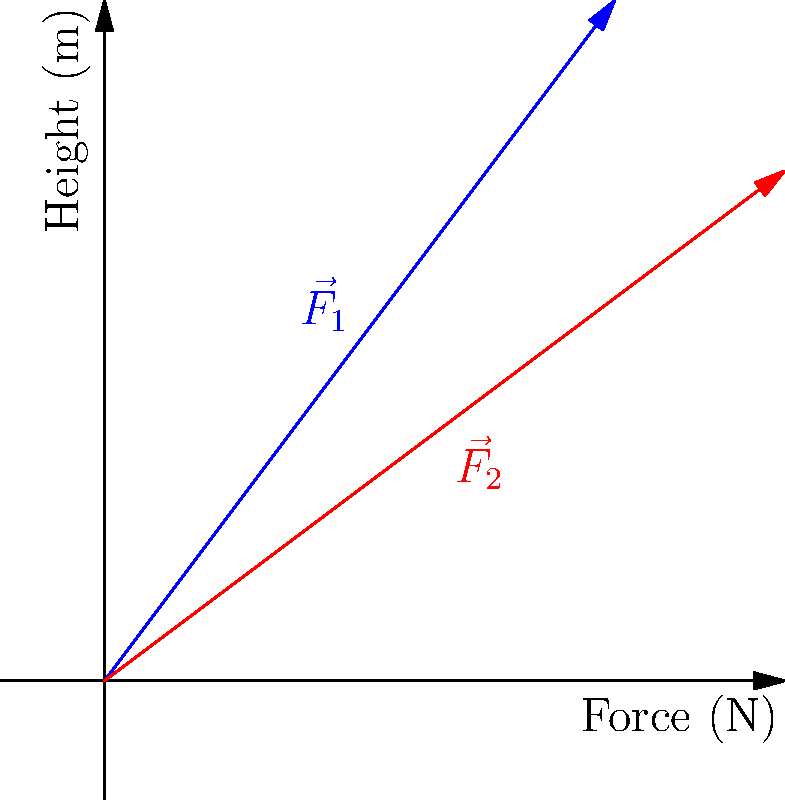In designing a low-impact exercise for a diabetic patient, you need to calculate the resultant force vector. Given two force vectors $\vec{F}_1 = 3\hat{i} + 4\hat{j}$ N and $\vec{F}_2 = 4\hat{i} + 3\hat{j}$ N, what is the magnitude of the resultant force vector to the nearest tenth of a Newton? To find the magnitude of the resultant force vector, we need to follow these steps:

1) The resultant force vector $\vec{R}$ is the sum of the two given vectors:
   $\vec{R} = \vec{F}_1 + \vec{F}_2$

2) Add the components:
   $\vec{R} = (3\hat{i} + 4\hat{j}) + (4\hat{i} + 3\hat{j})$
   $\vec{R} = (3+4)\hat{i} + (4+3)\hat{j}$
   $\vec{R} = 7\hat{i} + 7\hat{j}$

3) To find the magnitude, use the Pythagorean theorem:
   $|\vec{R}| = \sqrt{R_x^2 + R_y^2}$

4) Substitute the values:
   $|\vec{R}| = \sqrt{7^2 + 7^2}$

5) Calculate:
   $|\vec{R}| = \sqrt{98} \approx 9.899$ N

6) Rounding to the nearest tenth:
   $|\vec{R}| \approx 9.9$ N
Answer: 9.9 N 